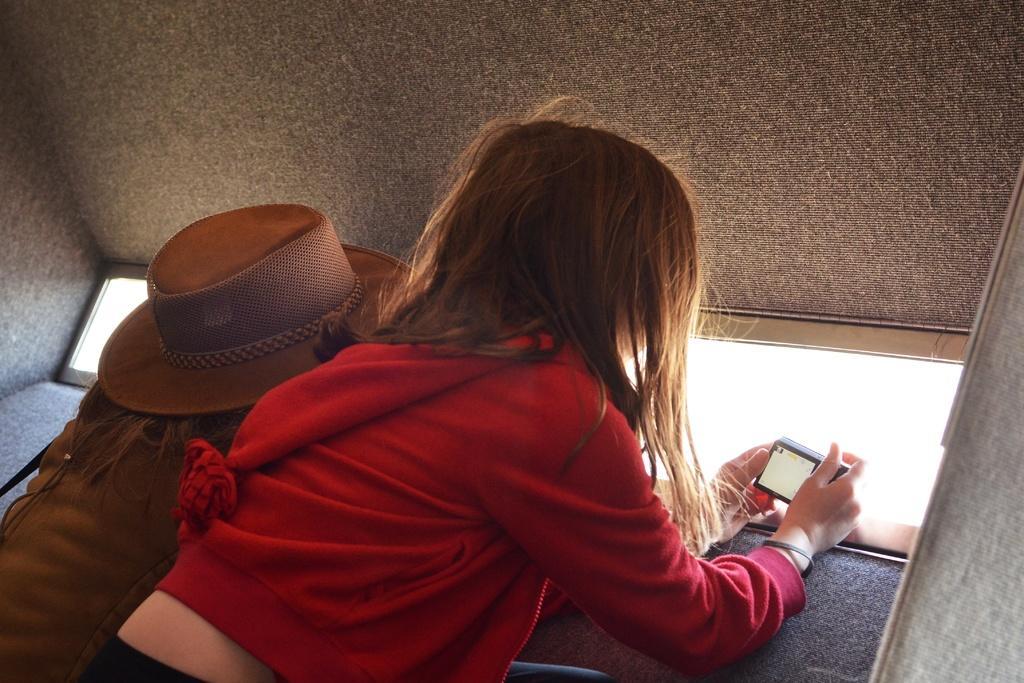Describe this image in one or two sentences. There is a girl holding a camera. Near to her another person is wearing a hat. 